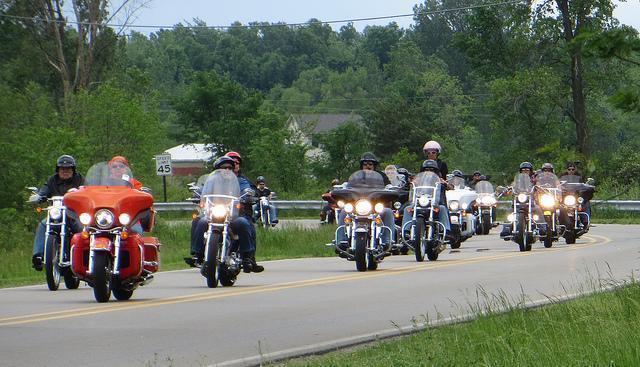What are the people doing with their motorcycles?
Indicate the correct response by choosing from the four available options to answer the question.
Options: Parading, protesting, looting, racing. Parading. 